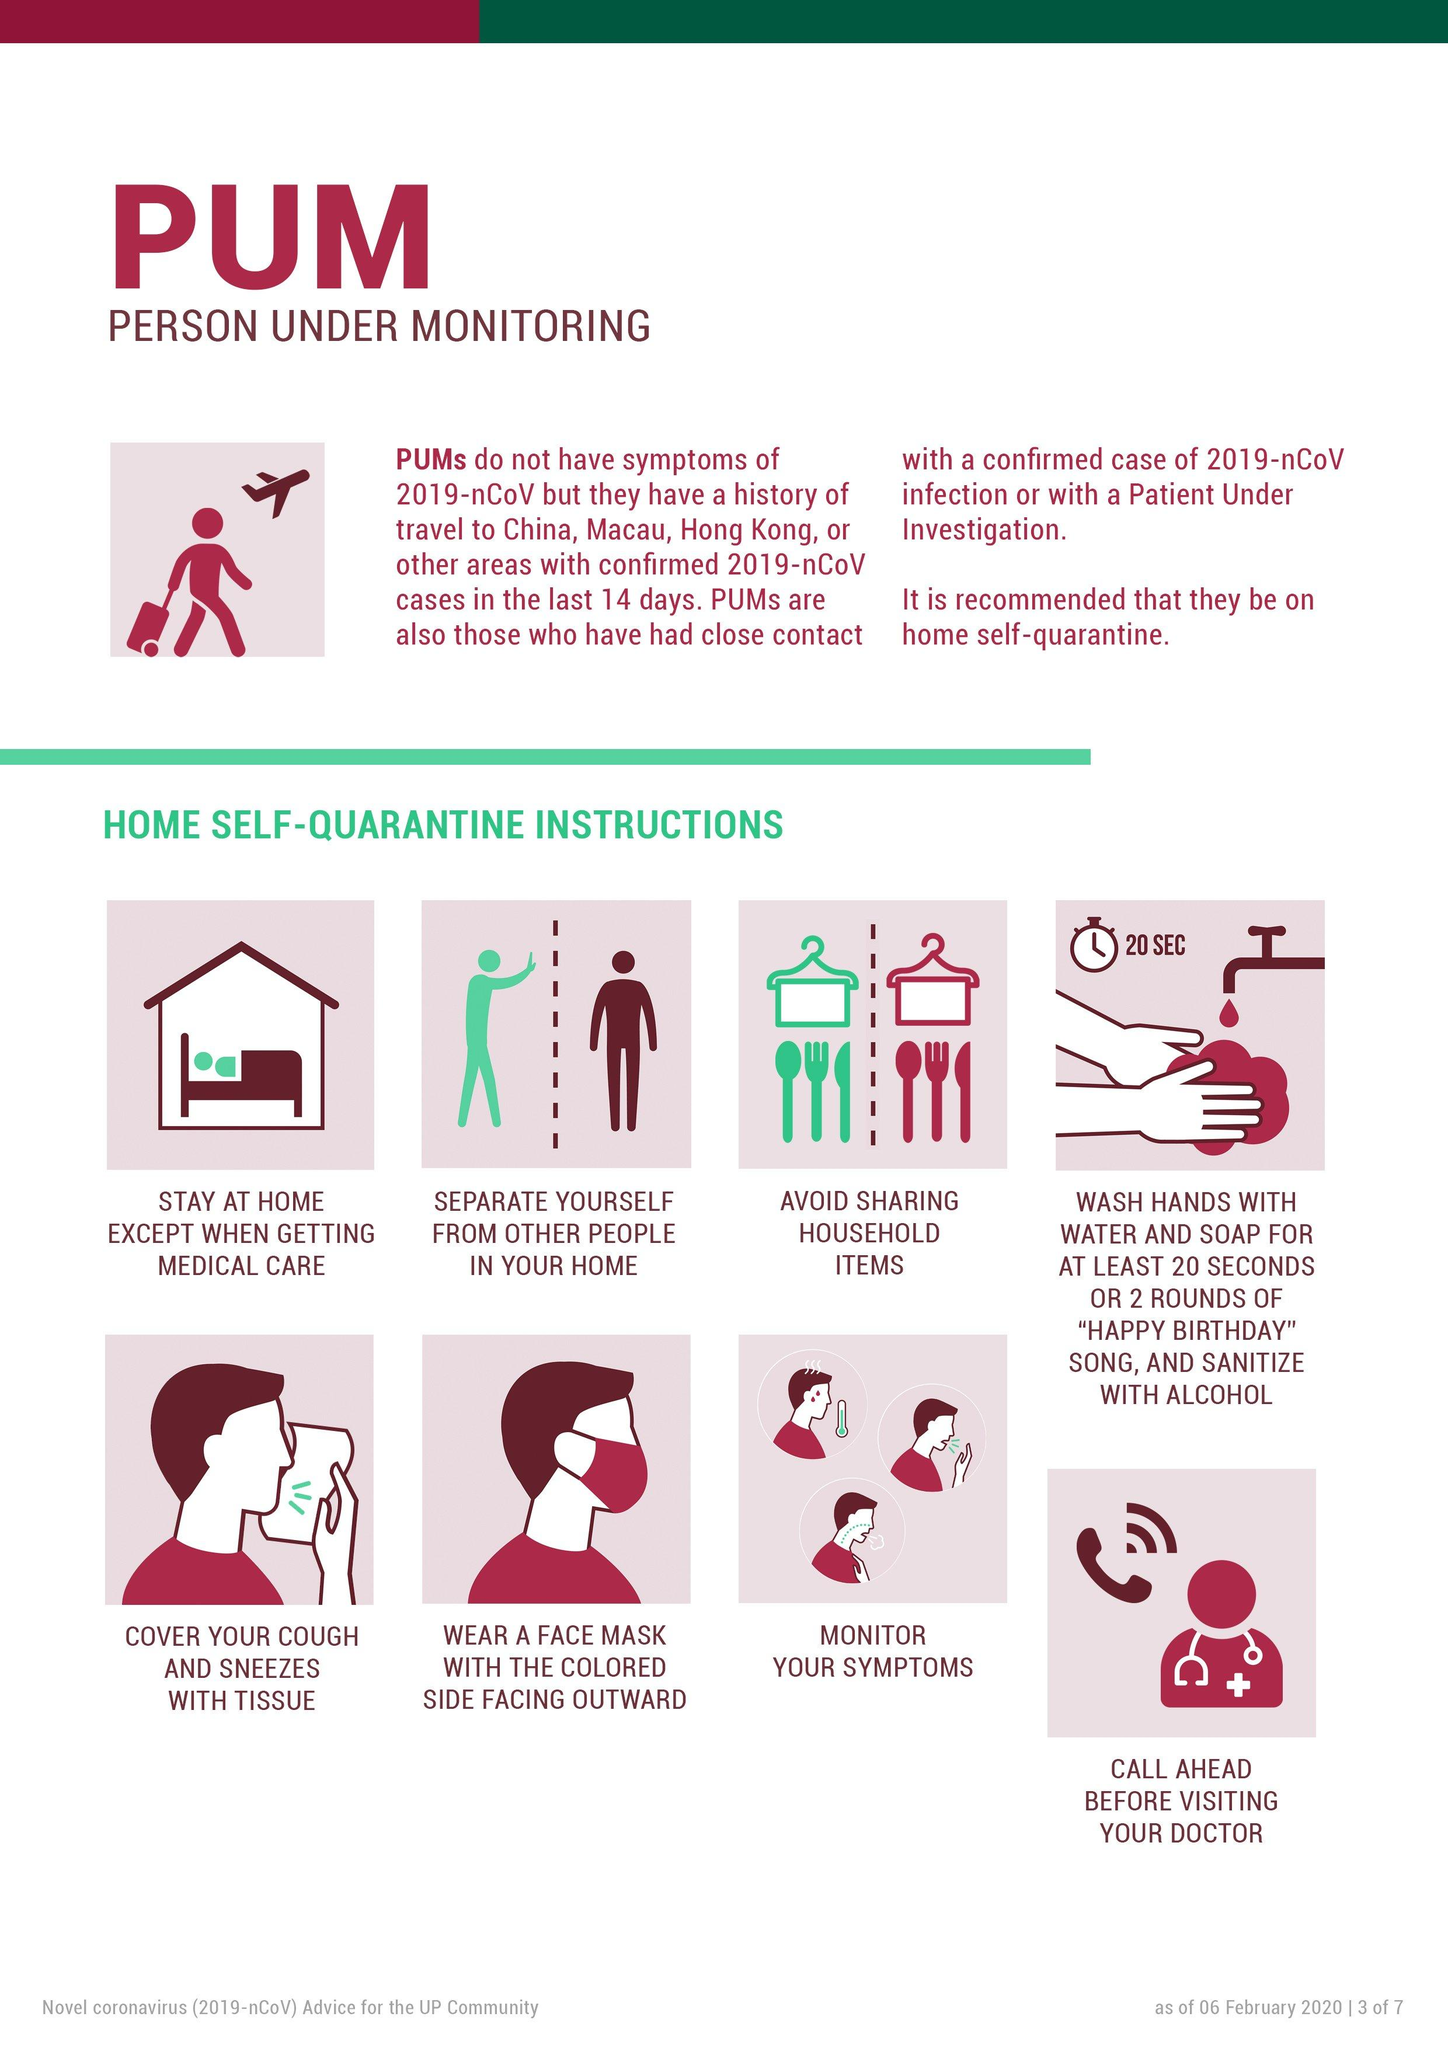Highlight a few significant elements in this photo. It is recommended that individuals wash their hands for at least 20 seconds in order to effectively prevent the spread of COVID-19. 